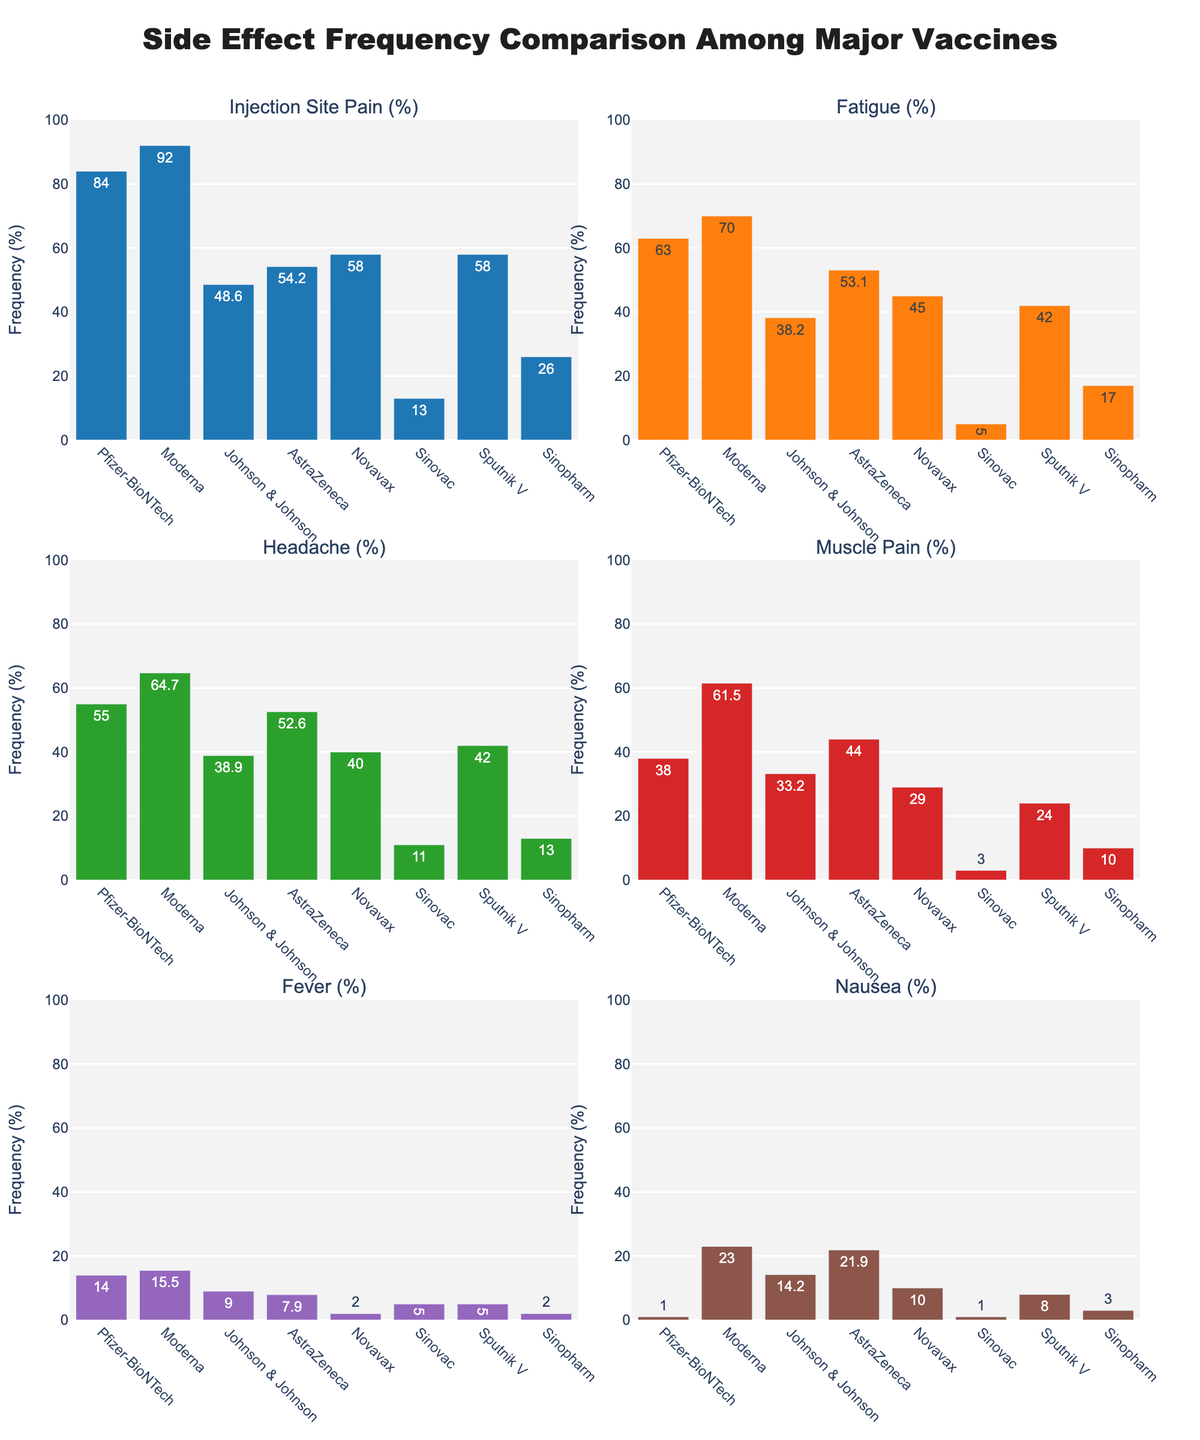Which vaccine has the highest reported frequency of injection site pain? Look at the bar chart for "Injection Site Pain (%)". The longest bar corresponds to Moderna, indicating the highest frequency.
Answer: Moderna What is the difference in frequency of fatigue between Pfizer-BioNTech and Novavax? Refer to the "Fatigue (%)" subplot. Pfizer-BioNTech has 63% and Novavax has 45%. The difference is calculated by subtracting 45% from 63%.
Answer: 18% Which vaccine shows the lowest frequency of nausea? In the subplot for "Nausea (%)", the shortest bar represents Pfizer-BioNTech, with a frequency of 1%.
Answer: Pfizer-BioNTech Compare the frequency of headache in Johnson & Johnson and AstraZeneca. Which one is higher and by how much? Refer to the "Headache (%)" subplot. Johnson & Johnson has 38.9% while AstraZeneca has 52.6%. AstraZeneca's frequency is higher. The difference is calculated by subtracting 38.9% from 52.6%.
Answer: AstraZeneca, 13.7% What is the combined frequency of muscle pain for all vaccines? Add the values from the "Muscle Pain (%)" subplot: 38% (Pfizer-BioNTech) + 61.5% (Moderna) + 33.2% (Johnson & Johnson) + 44% (AstraZeneca) + 29% (Novavax) + 3% (Sinovac) + 24% (Sputnik V) + 10% (Sinopharm) = 242.7%.
Answer: 242.7% Which side effect does the Pfizer-BioNTech vaccine report with the highest frequency? Look at the Pfizer-BioNTech bars across all subplots; the tallest bar is in the "Injection Site Pain (%)" subplot, at 84% frequency.
Answer: Injection Site Pain How does the frequency of fever in Sinovac compare to that in Sinopharm? Refer to the "Fever (%)" subplot. Sinovac has a 5% frequency, and Sinopharm has 2%. Sinovac has a higher frequency by 3%.
Answer: Sinovac, 3% Calculate the average frequency of injection site pain for all vaccines. Add the values from "Injection Site Pain (%)" subplot and divide by the number of vaccines: (84% + 92% + 48.6% + 54.2% + 58% + 13% + 58% + 26%) / 8 = 54.98%.
Answer: 54.98% Which vaccine shows the highest overall frequency for all side effects combined? Sum the frequencies of all side effects for each vaccine and compare. Moderna has the highest combined frequency: (92 + 70 + 64.7 + 61.5 + 15.5 + 23) = 326.7%.
Answer: Moderna 